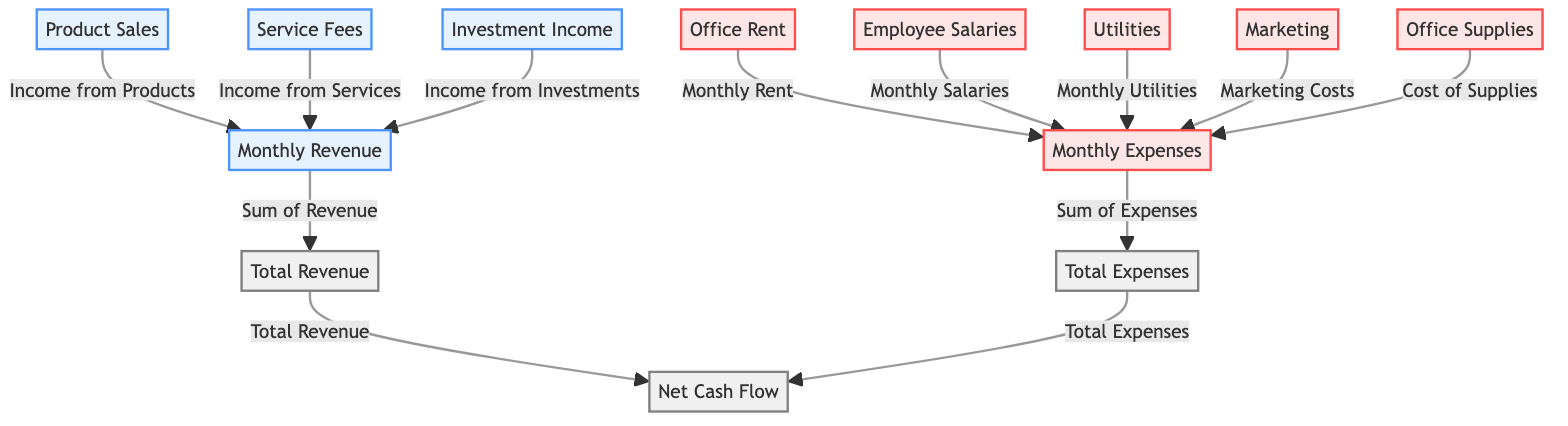What are the revenue sources listed in the diagram? The diagram shows three primary revenue sources: Product Sales, Service Fees, and Investment Income. These are highlighted in the revenue section.
Answer: Product Sales, Service Fees, Investment Income What is the total expense category in the diagram? The total expense category is labeled as "Total Expenses," which sums up all the individual expenses listed in the diagram.
Answer: Total Expenses How many types of expenses are shown in the diagram? The diagram illustrates five distinct types of expenses: Office Rent, Employee Salaries, Utilities, Marketing, and Office Supplies.
Answer: Five What is the relationship between total revenue and net cash flow? In the diagram, the total revenue directly influences the net cash flow, as indicated by the line connecting total revenue to net cash flow. The net cash flow is derived from total revenue minus total expenses.
Answer: Direct relationship Which expense category contributes the most significant impact to total expenses? The individual categories such as Employee Salaries and Office Rent likely represent the most substantial impacts on total expenses; however, the overall highest contributor isn't specifically stated and requires further financial analysis.
Answer: Not explicitly stated What is the role of investment income in the overall revenue? Investment income adds to the total revenue, contributing as one of the revenue sources alongside product sales and service fees, helping to increase overall cash flow.
Answer: Contributes to total revenue What does the net cash flow represent? The net cash flow represents the overall balance of revenues minus expenses for the month, indicating whether the business ended up with a profit or a loss.
Answer: Overall balance of revenues minus expenses Is there a connection between monthly expenses and net cash flow? Yes, the monthly expenses are directly connected to the net cash flow since total expenses are subtracted from total revenue to determine the net cash flow.
Answer: Yes, they are directly connected 